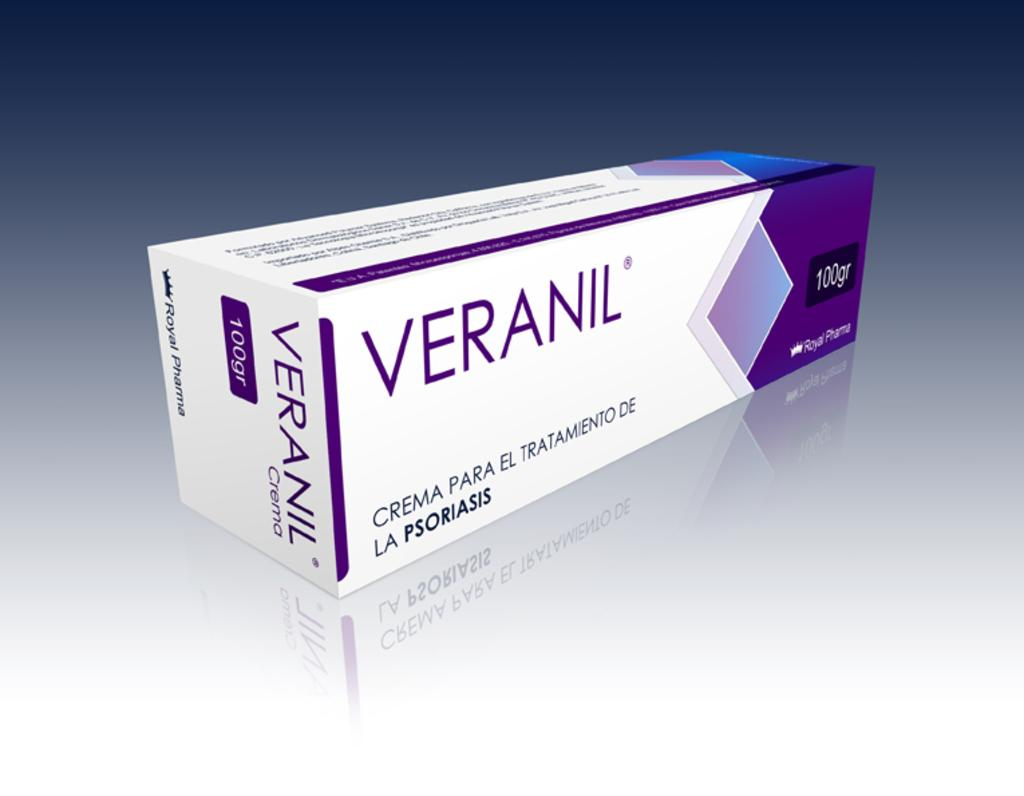<image>
Give a short and clear explanation of the subsequent image. A white and purple box containing the product Veranil was made by the company Royal Pharma. 